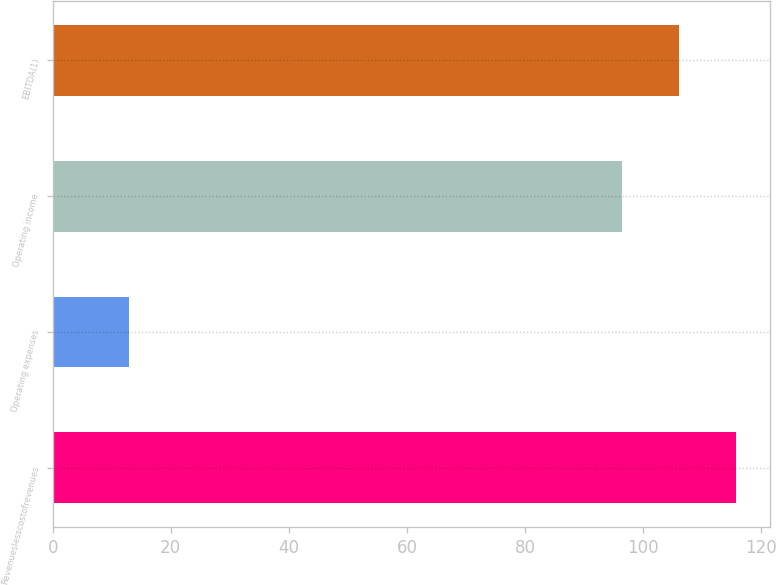<chart> <loc_0><loc_0><loc_500><loc_500><bar_chart><fcel>Revenueslesscostofrevenues<fcel>Operating expenses<fcel>Operating income<fcel>EBITDA(1)<nl><fcel>115.68<fcel>13<fcel>96.4<fcel>106.04<nl></chart> 